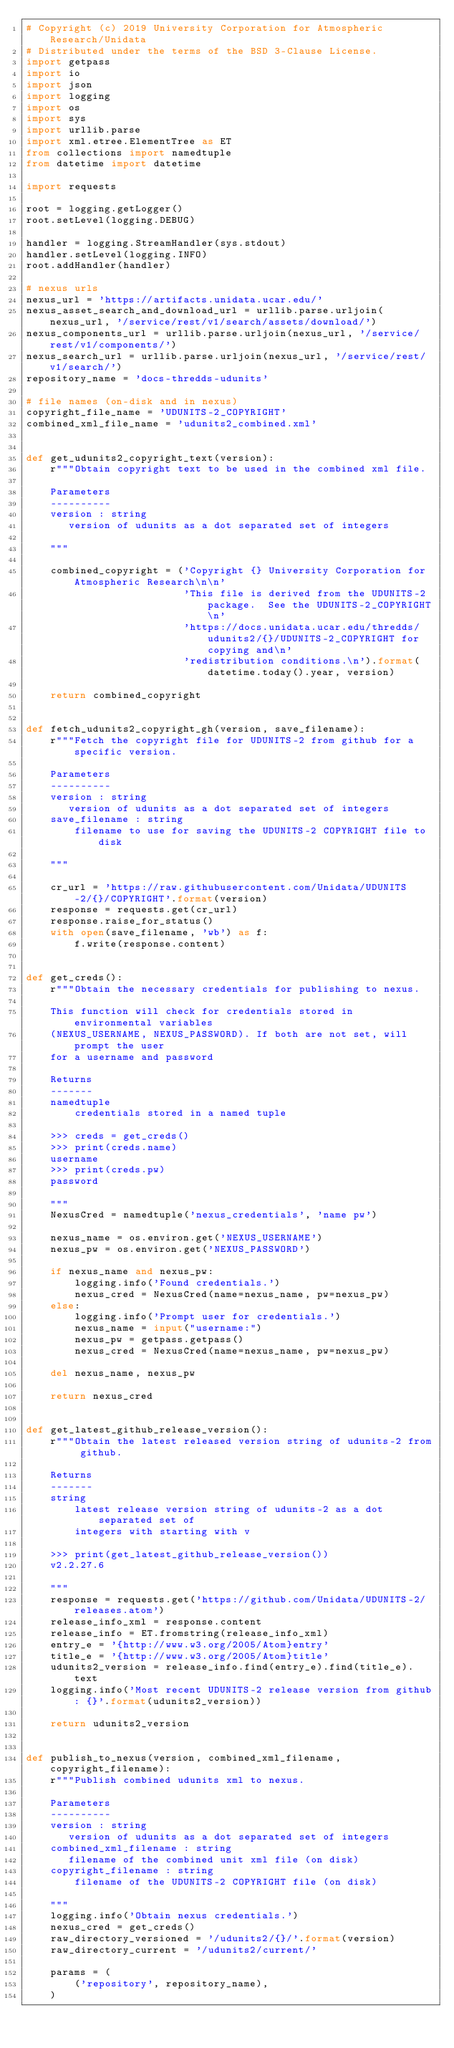Convert code to text. <code><loc_0><loc_0><loc_500><loc_500><_Python_># Copyright (c) 2019 University Corporation for Atmospheric Research/Unidata
# Distributed under the terms of the BSD 3-Clause License.
import getpass
import io
import json
import logging
import os
import sys
import urllib.parse
import xml.etree.ElementTree as ET
from collections import namedtuple
from datetime import datetime

import requests

root = logging.getLogger()
root.setLevel(logging.DEBUG)

handler = logging.StreamHandler(sys.stdout)
handler.setLevel(logging.INFO)
root.addHandler(handler)

# nexus urls
nexus_url = 'https://artifacts.unidata.ucar.edu/'
nexus_asset_search_and_download_url = urllib.parse.urljoin(nexus_url, '/service/rest/v1/search/assets/download/')
nexus_components_url = urllib.parse.urljoin(nexus_url, '/service/rest/v1/components/')
nexus_search_url = urllib.parse.urljoin(nexus_url, '/service/rest/v1/search/')
repository_name = 'docs-thredds-udunits'

# file names (on-disk and in nexus)
copyright_file_name = 'UDUNITS-2_COPYRIGHT'
combined_xml_file_name = 'udunits2_combined.xml'


def get_udunits2_copyright_text(version):
    r"""Obtain copyright text to be used in the combined xml file.

    Parameters
    ----------
    version : string
       version of udunits as a dot separated set of integers

    """

    combined_copyright = ('Copyright {} University Corporation for Atmospheric Research\n\n'
                          'This file is derived from the UDUNITS-2 package.  See the UDUNITS-2_COPYRIGHT\n'
                          'https://docs.unidata.ucar.edu/thredds/udunits2/{}/UDUNITS-2_COPYRIGHT for copying and\n'
                          'redistribution conditions.\n').format(datetime.today().year, version)

    return combined_copyright


def fetch_udunits2_copyright_gh(version, save_filename):
    r"""Fetch the copyright file for UDUNITS-2 from github for a specific version.

    Parameters
    ----------
    version : string
       version of udunits as a dot separated set of integers
    save_filename : string
        filename to use for saving the UDUNITS-2 COPYRIGHT file to disk

    """

    cr_url = 'https://raw.githubusercontent.com/Unidata/UDUNITS-2/{}/COPYRIGHT'.format(version)
    response = requests.get(cr_url)
    response.raise_for_status()
    with open(save_filename, 'wb') as f:
        f.write(response.content)


def get_creds():
    r"""Obtain the necessary credentials for publishing to nexus.

    This function will check for credentials stored in environmental variables
    (NEXUS_USERNAME, NEXUS_PASSWORD). If both are not set, will prompt the user
    for a username and password

    Returns
    -------
    namedtuple
        credentials stored in a named tuple

    >>> creds = get_creds()
    >>> print(creds.name)
    username
    >>> print(creds.pw)
    password

    """
    NexusCred = namedtuple('nexus_credentials', 'name pw')

    nexus_name = os.environ.get('NEXUS_USERNAME')
    nexus_pw = os.environ.get('NEXUS_PASSWORD')

    if nexus_name and nexus_pw:
        logging.info('Found credentials.')
        nexus_cred = NexusCred(name=nexus_name, pw=nexus_pw)
    else:
        logging.info('Prompt user for credentials.')
        nexus_name = input("username:")
        nexus_pw = getpass.getpass()
        nexus_cred = NexusCred(name=nexus_name, pw=nexus_pw)

    del nexus_name, nexus_pw

    return nexus_cred


def get_latest_github_release_version():
    r"""Obtain the latest released version string of udunits-2 from github.

    Returns
    -------
    string
        latest release version string of udunits-2 as a dot separated set of
        integers with starting with v

    >>> print(get_latest_github_release_version())
    v2.2.27.6

    """
    response = requests.get('https://github.com/Unidata/UDUNITS-2/releases.atom')
    release_info_xml = response.content
    release_info = ET.fromstring(release_info_xml)
    entry_e = '{http://www.w3.org/2005/Atom}entry'
    title_e = '{http://www.w3.org/2005/Atom}title'
    udunits2_version = release_info.find(entry_e).find(title_e).text
    logging.info('Most recent UDUNITS-2 release version from github: {}'.format(udunits2_version))

    return udunits2_version


def publish_to_nexus(version, combined_xml_filename, copyright_filename):
    r"""Publish combined udunits xml to nexus.

    Parameters
    ----------
    version : string
       version of udunits as a dot separated set of integers
    combined_xml_filename : string
       filename of the combined unit xml file (on disk)
    copyright_filename : string
        filename of the UDUNITS-2 COPYRIGHT file (on disk)

    """
    logging.info('Obtain nexus credentials.')
    nexus_cred = get_creds()
    raw_directory_versioned = '/udunits2/{}/'.format(version)
    raw_directory_current = '/udunits2/current/'

    params = (
        ('repository', repository_name),
    )
</code> 